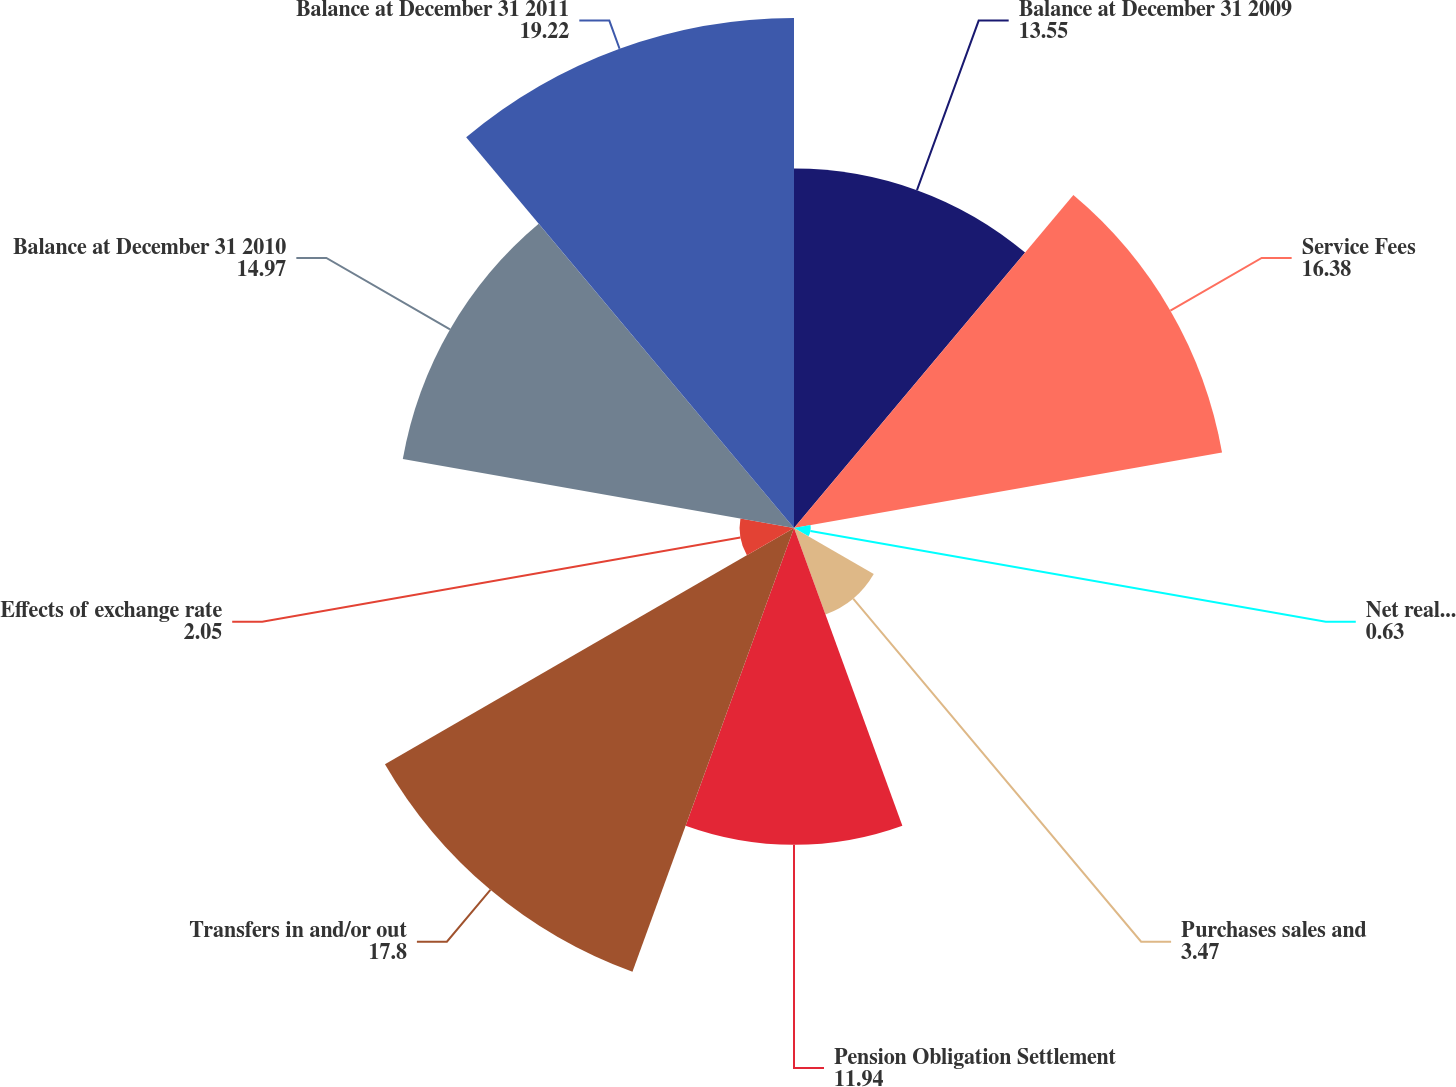Convert chart. <chart><loc_0><loc_0><loc_500><loc_500><pie_chart><fcel>Balance at December 31 2009<fcel>Service Fees<fcel>Net realized and unrealized<fcel>Purchases sales and<fcel>Pension Obligation Settlement<fcel>Transfers in and/or out<fcel>Effects of exchange rate<fcel>Balance at December 31 2010<fcel>Balance at December 31 2011<nl><fcel>13.55%<fcel>16.38%<fcel>0.63%<fcel>3.47%<fcel>11.94%<fcel>17.8%<fcel>2.05%<fcel>14.97%<fcel>19.22%<nl></chart> 